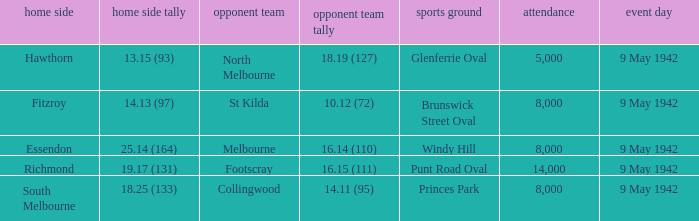How many people attended the game where Footscray was away? 14000.0. 